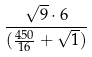Convert formula to latex. <formula><loc_0><loc_0><loc_500><loc_500>\frac { \sqrt { 9 } \cdot 6 } { ( \frac { 4 5 0 } { 1 6 } + \sqrt { 1 } ) }</formula> 